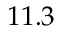Convert formula to latex. <formula><loc_0><loc_0><loc_500><loc_500>1 1 . 3</formula> 